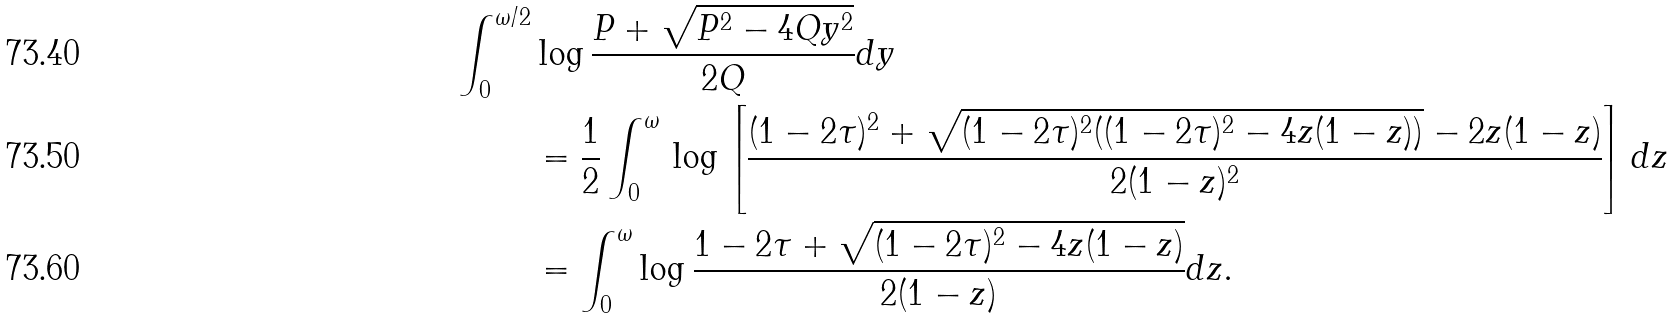<formula> <loc_0><loc_0><loc_500><loc_500>\int _ { 0 } ^ { \omega / 2 } & \log \frac { P + \sqrt { P ^ { 2 } - 4 Q y ^ { 2 } } } { 2 Q } d y \\ & = \frac { 1 } { 2 } \int _ { 0 } ^ { \omega } \, \log \left [ \frac { ( 1 - 2 \tau ) ^ { 2 } + \sqrt { ( 1 - 2 \tau ) ^ { 2 } ( ( 1 - 2 \tau ) ^ { 2 } - 4 z ( 1 - z ) ) } - 2 z ( 1 - z ) } { 2 ( 1 - z ) ^ { 2 } } \right ] d z \\ & = \int _ { 0 } ^ { \omega } \log \frac { 1 - 2 \tau + \sqrt { ( 1 - 2 \tau ) ^ { 2 } - 4 z ( 1 - z ) } } { 2 ( 1 - z ) } d z .</formula> 